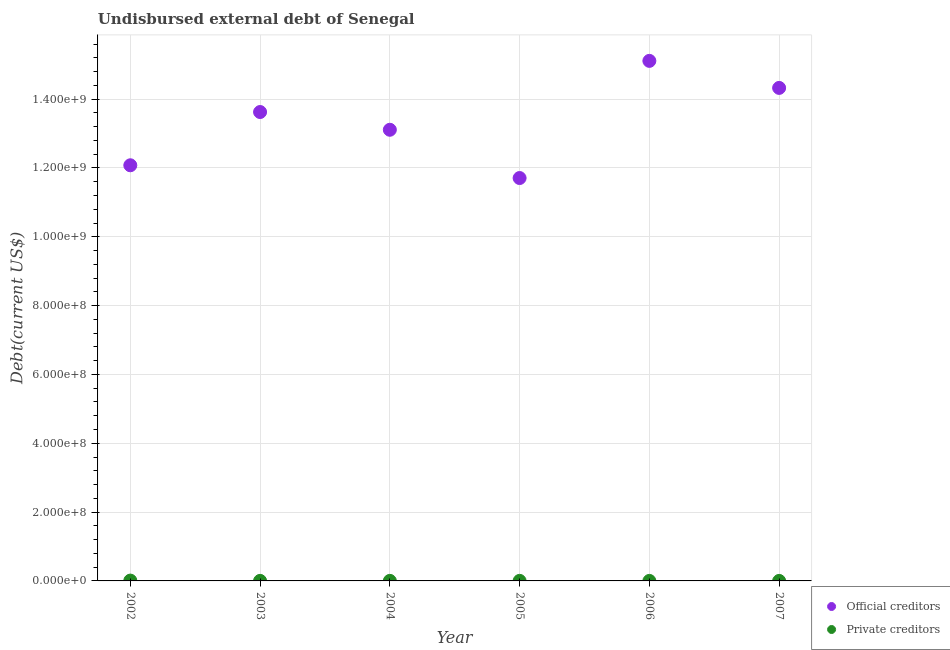How many different coloured dotlines are there?
Make the answer very short. 2. Is the number of dotlines equal to the number of legend labels?
Provide a succinct answer. Yes. What is the undisbursed external debt of official creditors in 2007?
Make the answer very short. 1.43e+09. Across all years, what is the maximum undisbursed external debt of private creditors?
Make the answer very short. 9.55e+05. Across all years, what is the minimum undisbursed external debt of private creditors?
Offer a very short reply. 1.20e+04. In which year was the undisbursed external debt of official creditors maximum?
Keep it short and to the point. 2006. What is the total undisbursed external debt of private creditors in the graph?
Ensure brevity in your answer.  1.40e+06. What is the difference between the undisbursed external debt of official creditors in 2003 and that in 2004?
Give a very brief answer. 5.16e+07. What is the difference between the undisbursed external debt of private creditors in 2006 and the undisbursed external debt of official creditors in 2004?
Provide a succinct answer. -1.31e+09. What is the average undisbursed external debt of official creditors per year?
Your answer should be compact. 1.33e+09. In the year 2003, what is the difference between the undisbursed external debt of official creditors and undisbursed external debt of private creditors?
Keep it short and to the point. 1.36e+09. In how many years, is the undisbursed external debt of official creditors greater than 880000000 US$?
Give a very brief answer. 6. What is the ratio of the undisbursed external debt of official creditors in 2005 to that in 2007?
Keep it short and to the point. 0.82. Is the difference between the undisbursed external debt of official creditors in 2004 and 2006 greater than the difference between the undisbursed external debt of private creditors in 2004 and 2006?
Offer a terse response. No. What is the difference between the highest and the second highest undisbursed external debt of official creditors?
Your answer should be very brief. 7.86e+07. What is the difference between the highest and the lowest undisbursed external debt of private creditors?
Keep it short and to the point. 9.43e+05. Is the sum of the undisbursed external debt of private creditors in 2002 and 2007 greater than the maximum undisbursed external debt of official creditors across all years?
Offer a terse response. No. Is the undisbursed external debt of private creditors strictly less than the undisbursed external debt of official creditors over the years?
Provide a short and direct response. Yes. Are the values on the major ticks of Y-axis written in scientific E-notation?
Offer a terse response. Yes. Does the graph contain any zero values?
Provide a short and direct response. No. Does the graph contain grids?
Give a very brief answer. Yes. What is the title of the graph?
Offer a very short reply. Undisbursed external debt of Senegal. What is the label or title of the X-axis?
Offer a terse response. Year. What is the label or title of the Y-axis?
Keep it short and to the point. Debt(current US$). What is the Debt(current US$) of Official creditors in 2002?
Offer a very short reply. 1.21e+09. What is the Debt(current US$) in Private creditors in 2002?
Offer a very short reply. 9.55e+05. What is the Debt(current US$) in Official creditors in 2003?
Your answer should be compact. 1.36e+09. What is the Debt(current US$) of Private creditors in 2003?
Make the answer very short. 1.40e+05. What is the Debt(current US$) of Official creditors in 2004?
Ensure brevity in your answer.  1.31e+09. What is the Debt(current US$) of Private creditors in 2004?
Your answer should be compact. 1.41e+05. What is the Debt(current US$) of Official creditors in 2005?
Ensure brevity in your answer.  1.17e+09. What is the Debt(current US$) of Private creditors in 2005?
Ensure brevity in your answer.  1.39e+05. What is the Debt(current US$) of Official creditors in 2006?
Make the answer very short. 1.51e+09. What is the Debt(current US$) of Private creditors in 2006?
Offer a very short reply. 1.20e+04. What is the Debt(current US$) in Official creditors in 2007?
Provide a short and direct response. 1.43e+09. What is the Debt(current US$) of Private creditors in 2007?
Ensure brevity in your answer.  1.30e+04. Across all years, what is the maximum Debt(current US$) in Official creditors?
Your response must be concise. 1.51e+09. Across all years, what is the maximum Debt(current US$) of Private creditors?
Give a very brief answer. 9.55e+05. Across all years, what is the minimum Debt(current US$) in Official creditors?
Give a very brief answer. 1.17e+09. Across all years, what is the minimum Debt(current US$) of Private creditors?
Provide a short and direct response. 1.20e+04. What is the total Debt(current US$) in Official creditors in the graph?
Ensure brevity in your answer.  8.00e+09. What is the total Debt(current US$) of Private creditors in the graph?
Your answer should be compact. 1.40e+06. What is the difference between the Debt(current US$) of Official creditors in 2002 and that in 2003?
Your answer should be compact. -1.55e+08. What is the difference between the Debt(current US$) of Private creditors in 2002 and that in 2003?
Provide a succinct answer. 8.15e+05. What is the difference between the Debt(current US$) of Official creditors in 2002 and that in 2004?
Offer a very short reply. -1.03e+08. What is the difference between the Debt(current US$) in Private creditors in 2002 and that in 2004?
Ensure brevity in your answer.  8.14e+05. What is the difference between the Debt(current US$) of Official creditors in 2002 and that in 2005?
Make the answer very short. 3.71e+07. What is the difference between the Debt(current US$) in Private creditors in 2002 and that in 2005?
Provide a succinct answer. 8.16e+05. What is the difference between the Debt(current US$) of Official creditors in 2002 and that in 2006?
Give a very brief answer. -3.03e+08. What is the difference between the Debt(current US$) in Private creditors in 2002 and that in 2006?
Give a very brief answer. 9.43e+05. What is the difference between the Debt(current US$) in Official creditors in 2002 and that in 2007?
Offer a terse response. -2.25e+08. What is the difference between the Debt(current US$) of Private creditors in 2002 and that in 2007?
Your answer should be compact. 9.42e+05. What is the difference between the Debt(current US$) of Official creditors in 2003 and that in 2004?
Offer a very short reply. 5.16e+07. What is the difference between the Debt(current US$) in Private creditors in 2003 and that in 2004?
Make the answer very short. -1000. What is the difference between the Debt(current US$) in Official creditors in 2003 and that in 2005?
Your answer should be very brief. 1.92e+08. What is the difference between the Debt(current US$) in Official creditors in 2003 and that in 2006?
Give a very brief answer. -1.49e+08. What is the difference between the Debt(current US$) in Private creditors in 2003 and that in 2006?
Provide a succinct answer. 1.28e+05. What is the difference between the Debt(current US$) of Official creditors in 2003 and that in 2007?
Provide a short and direct response. -7.01e+07. What is the difference between the Debt(current US$) of Private creditors in 2003 and that in 2007?
Your response must be concise. 1.27e+05. What is the difference between the Debt(current US$) of Official creditors in 2004 and that in 2005?
Ensure brevity in your answer.  1.40e+08. What is the difference between the Debt(current US$) in Private creditors in 2004 and that in 2005?
Ensure brevity in your answer.  2000. What is the difference between the Debt(current US$) of Official creditors in 2004 and that in 2006?
Keep it short and to the point. -2.00e+08. What is the difference between the Debt(current US$) of Private creditors in 2004 and that in 2006?
Make the answer very short. 1.29e+05. What is the difference between the Debt(current US$) in Official creditors in 2004 and that in 2007?
Offer a very short reply. -1.22e+08. What is the difference between the Debt(current US$) of Private creditors in 2004 and that in 2007?
Offer a very short reply. 1.28e+05. What is the difference between the Debt(current US$) of Official creditors in 2005 and that in 2006?
Offer a terse response. -3.40e+08. What is the difference between the Debt(current US$) of Private creditors in 2005 and that in 2006?
Offer a terse response. 1.27e+05. What is the difference between the Debt(current US$) in Official creditors in 2005 and that in 2007?
Your answer should be compact. -2.62e+08. What is the difference between the Debt(current US$) in Private creditors in 2005 and that in 2007?
Your answer should be very brief. 1.26e+05. What is the difference between the Debt(current US$) in Official creditors in 2006 and that in 2007?
Ensure brevity in your answer.  7.86e+07. What is the difference between the Debt(current US$) in Private creditors in 2006 and that in 2007?
Give a very brief answer. -1000. What is the difference between the Debt(current US$) of Official creditors in 2002 and the Debt(current US$) of Private creditors in 2003?
Offer a very short reply. 1.21e+09. What is the difference between the Debt(current US$) in Official creditors in 2002 and the Debt(current US$) in Private creditors in 2004?
Your answer should be very brief. 1.21e+09. What is the difference between the Debt(current US$) of Official creditors in 2002 and the Debt(current US$) of Private creditors in 2005?
Your answer should be compact. 1.21e+09. What is the difference between the Debt(current US$) of Official creditors in 2002 and the Debt(current US$) of Private creditors in 2006?
Offer a terse response. 1.21e+09. What is the difference between the Debt(current US$) of Official creditors in 2002 and the Debt(current US$) of Private creditors in 2007?
Give a very brief answer. 1.21e+09. What is the difference between the Debt(current US$) of Official creditors in 2003 and the Debt(current US$) of Private creditors in 2004?
Offer a very short reply. 1.36e+09. What is the difference between the Debt(current US$) in Official creditors in 2003 and the Debt(current US$) in Private creditors in 2005?
Give a very brief answer. 1.36e+09. What is the difference between the Debt(current US$) in Official creditors in 2003 and the Debt(current US$) in Private creditors in 2006?
Make the answer very short. 1.36e+09. What is the difference between the Debt(current US$) in Official creditors in 2003 and the Debt(current US$) in Private creditors in 2007?
Make the answer very short. 1.36e+09. What is the difference between the Debt(current US$) of Official creditors in 2004 and the Debt(current US$) of Private creditors in 2005?
Ensure brevity in your answer.  1.31e+09. What is the difference between the Debt(current US$) of Official creditors in 2004 and the Debt(current US$) of Private creditors in 2006?
Your answer should be very brief. 1.31e+09. What is the difference between the Debt(current US$) in Official creditors in 2004 and the Debt(current US$) in Private creditors in 2007?
Offer a terse response. 1.31e+09. What is the difference between the Debt(current US$) in Official creditors in 2005 and the Debt(current US$) in Private creditors in 2006?
Give a very brief answer. 1.17e+09. What is the difference between the Debt(current US$) of Official creditors in 2005 and the Debt(current US$) of Private creditors in 2007?
Make the answer very short. 1.17e+09. What is the difference between the Debt(current US$) in Official creditors in 2006 and the Debt(current US$) in Private creditors in 2007?
Give a very brief answer. 1.51e+09. What is the average Debt(current US$) of Official creditors per year?
Your answer should be compact. 1.33e+09. What is the average Debt(current US$) in Private creditors per year?
Your response must be concise. 2.33e+05. In the year 2002, what is the difference between the Debt(current US$) in Official creditors and Debt(current US$) in Private creditors?
Offer a very short reply. 1.21e+09. In the year 2003, what is the difference between the Debt(current US$) in Official creditors and Debt(current US$) in Private creditors?
Offer a terse response. 1.36e+09. In the year 2004, what is the difference between the Debt(current US$) in Official creditors and Debt(current US$) in Private creditors?
Make the answer very short. 1.31e+09. In the year 2005, what is the difference between the Debt(current US$) of Official creditors and Debt(current US$) of Private creditors?
Ensure brevity in your answer.  1.17e+09. In the year 2006, what is the difference between the Debt(current US$) in Official creditors and Debt(current US$) in Private creditors?
Make the answer very short. 1.51e+09. In the year 2007, what is the difference between the Debt(current US$) in Official creditors and Debt(current US$) in Private creditors?
Make the answer very short. 1.43e+09. What is the ratio of the Debt(current US$) of Official creditors in 2002 to that in 2003?
Make the answer very short. 0.89. What is the ratio of the Debt(current US$) of Private creditors in 2002 to that in 2003?
Offer a terse response. 6.82. What is the ratio of the Debt(current US$) of Official creditors in 2002 to that in 2004?
Your answer should be compact. 0.92. What is the ratio of the Debt(current US$) in Private creditors in 2002 to that in 2004?
Your answer should be very brief. 6.77. What is the ratio of the Debt(current US$) of Official creditors in 2002 to that in 2005?
Keep it short and to the point. 1.03. What is the ratio of the Debt(current US$) of Private creditors in 2002 to that in 2005?
Provide a succinct answer. 6.87. What is the ratio of the Debt(current US$) in Official creditors in 2002 to that in 2006?
Give a very brief answer. 0.8. What is the ratio of the Debt(current US$) in Private creditors in 2002 to that in 2006?
Ensure brevity in your answer.  79.58. What is the ratio of the Debt(current US$) in Official creditors in 2002 to that in 2007?
Your answer should be compact. 0.84. What is the ratio of the Debt(current US$) of Private creditors in 2002 to that in 2007?
Ensure brevity in your answer.  73.46. What is the ratio of the Debt(current US$) in Official creditors in 2003 to that in 2004?
Your answer should be very brief. 1.04. What is the ratio of the Debt(current US$) of Official creditors in 2003 to that in 2005?
Your answer should be very brief. 1.16. What is the ratio of the Debt(current US$) of Official creditors in 2003 to that in 2006?
Keep it short and to the point. 0.9. What is the ratio of the Debt(current US$) in Private creditors in 2003 to that in 2006?
Your answer should be very brief. 11.67. What is the ratio of the Debt(current US$) in Official creditors in 2003 to that in 2007?
Your answer should be compact. 0.95. What is the ratio of the Debt(current US$) of Private creditors in 2003 to that in 2007?
Provide a succinct answer. 10.77. What is the ratio of the Debt(current US$) in Official creditors in 2004 to that in 2005?
Make the answer very short. 1.12. What is the ratio of the Debt(current US$) of Private creditors in 2004 to that in 2005?
Your answer should be compact. 1.01. What is the ratio of the Debt(current US$) of Official creditors in 2004 to that in 2006?
Ensure brevity in your answer.  0.87. What is the ratio of the Debt(current US$) in Private creditors in 2004 to that in 2006?
Your response must be concise. 11.75. What is the ratio of the Debt(current US$) of Official creditors in 2004 to that in 2007?
Your response must be concise. 0.92. What is the ratio of the Debt(current US$) in Private creditors in 2004 to that in 2007?
Keep it short and to the point. 10.85. What is the ratio of the Debt(current US$) in Official creditors in 2005 to that in 2006?
Provide a short and direct response. 0.77. What is the ratio of the Debt(current US$) in Private creditors in 2005 to that in 2006?
Offer a terse response. 11.58. What is the ratio of the Debt(current US$) of Official creditors in 2005 to that in 2007?
Ensure brevity in your answer.  0.82. What is the ratio of the Debt(current US$) in Private creditors in 2005 to that in 2007?
Give a very brief answer. 10.69. What is the ratio of the Debt(current US$) in Official creditors in 2006 to that in 2007?
Offer a terse response. 1.05. What is the ratio of the Debt(current US$) in Private creditors in 2006 to that in 2007?
Provide a succinct answer. 0.92. What is the difference between the highest and the second highest Debt(current US$) of Official creditors?
Your answer should be very brief. 7.86e+07. What is the difference between the highest and the second highest Debt(current US$) in Private creditors?
Provide a succinct answer. 8.14e+05. What is the difference between the highest and the lowest Debt(current US$) in Official creditors?
Provide a succinct answer. 3.40e+08. What is the difference between the highest and the lowest Debt(current US$) of Private creditors?
Your answer should be compact. 9.43e+05. 